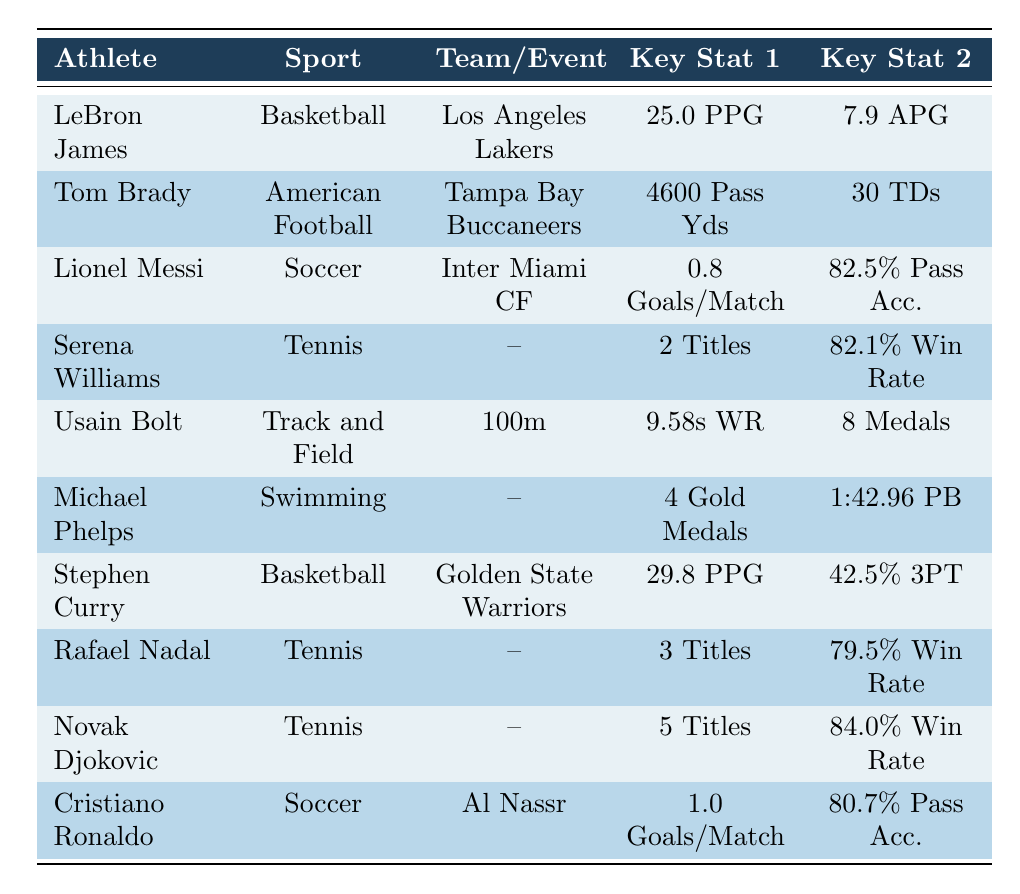What is LeBron James' points per game? LeBron James is listed in the table under Basketball with the team Los Angeles Lakers, where his points per game is specifically stated as 25.0.
Answer: 25.0 PPG How many touchdowns did Tom Brady throw in 2023? The table shows Tom Brady's statistics under American Football with the team Tampa Bay Buccaneers, indicating he threw 30 touchdowns.
Answer: 30 TDs Which athlete has the highest win percentage in tennis? The win percentages of Rafael Nadal (79.5%), Novak Djokovic (84.0%), and Serena Williams (82.1%) are given. Among these, Novak Djokovic has the highest win percentage at 84.0%.
Answer: 84.0% What is the average goals per match for Messi and Ronaldo combined? Lionel Messi scores 0.8 goals per match and Cristiano Ronaldo scores 1.0 goals per match. Adding them together gives a total of 1.8 goals. Dividing by 2, the average is 1.8/2 = 0.9.
Answer: 0.9 Is Stephen Curry's three-point percentage greater than 40%? The table shows Stephen Curry's three-point percentage as 42.5%, which is indeed greater than 40%.
Answer: Yes How many gold medals does Michael Phelps have compared to Usain Bolt? Michael Phelps has 4 gold medals, while Usain Bolt has 8 medals total. Since the gold medal count is not provided for Bolt, this means Phelps has fewer gold medals compared to Bolt's total medals.
Answer: 4 vs 8 (Phelps has fewer) What is the total number of titles won by the three tennis players in the table? Serena Williams has 2 titles, Rafael Nadal has 3 titles, and Novak Djokovic has 5 titles. Adding these: 2 + 3 + 5 = 10 titles won in total.
Answer: 10 Titles Which athlete participates in the 100m event? The table lists Usain Bolt under Track and Field, specifically indicating his event as the 100m.
Answer: Usain Bolt How many assists per match does Cristiano Ronaldo have? The table shows Cristiano Ronaldo's assists per match as 0.3, directly stated in his soccer statistics.
Answer: 0.3 Assist/Match 